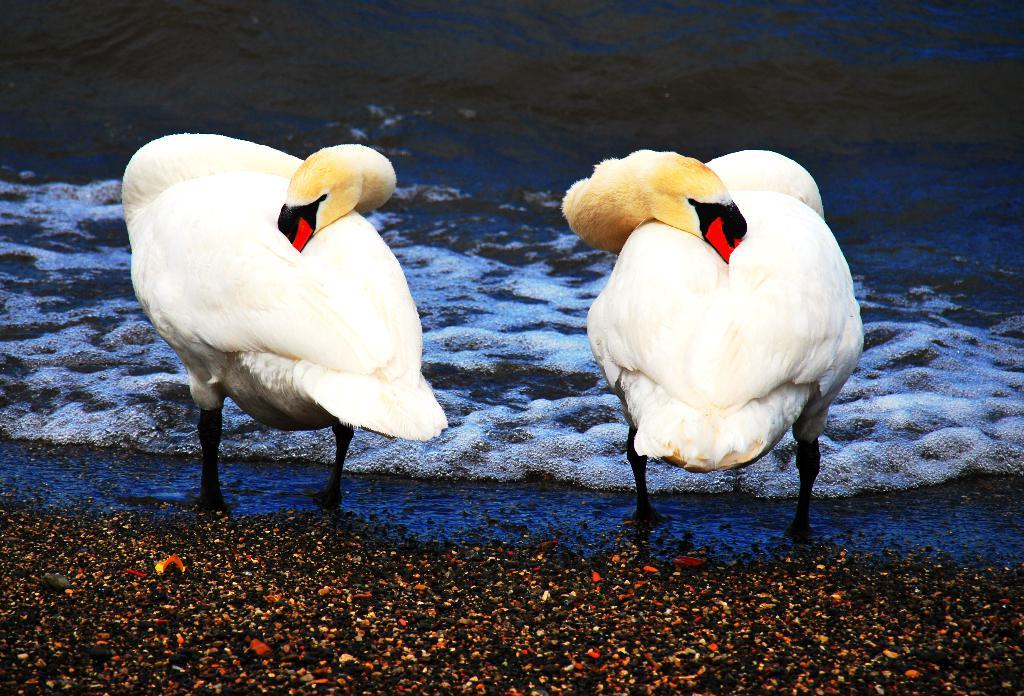How many birds can be seen in the image? There are two birds in the image. What colors are the birds? The birds are in white, black, red, and brown colors. Where are the birds located in the image? The birds are standing on the water. What color is the water in the background? The water in the background is blue. What type of tub can be seen in the image? There is no tub present in the image; it features two birds standing on the water. How many oranges are visible in the image? There are no oranges present in the image. 